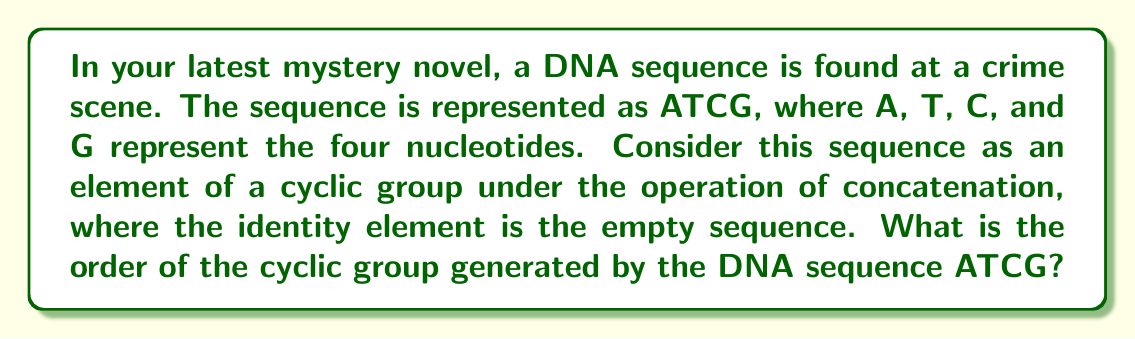Can you solve this math problem? To solve this problem, we need to follow these steps:

1) First, recall that the order of an element in a group is the smallest positive integer $n$ such that $a^n = e$, where $a$ is the element and $e$ is the identity element.

2) In this case, our element is the DNA sequence ATCG, and the operation is concatenation. The identity element is the empty sequence.

3) Let's see what happens when we concatenate ATCG with itself multiple times:

   $(ATCG)^1 = ATCG$
   $(ATCG)^2 = ATCGATCG$
   $(ATCG)^3 = ATCGATCGATCG$
   $(ATCG)^4 = ATCGATCGATCGATCG$

4) We can see that no matter how many times we concatenate ATCG with itself, we will never get the empty sequence. This is because DNA sequences don't have inverse elements under concatenation.

5) Therefore, the cyclic group generated by ATCG is infinite. In group theory, we say that the order of this group is $\infty$.

6) This infinite cyclic group is isomorphic to the additive group of integers, $(\mathbb{Z}, +)$.
Answer: The order of the cyclic group generated by the DNA sequence ATCG is $\infty$ (infinity). 